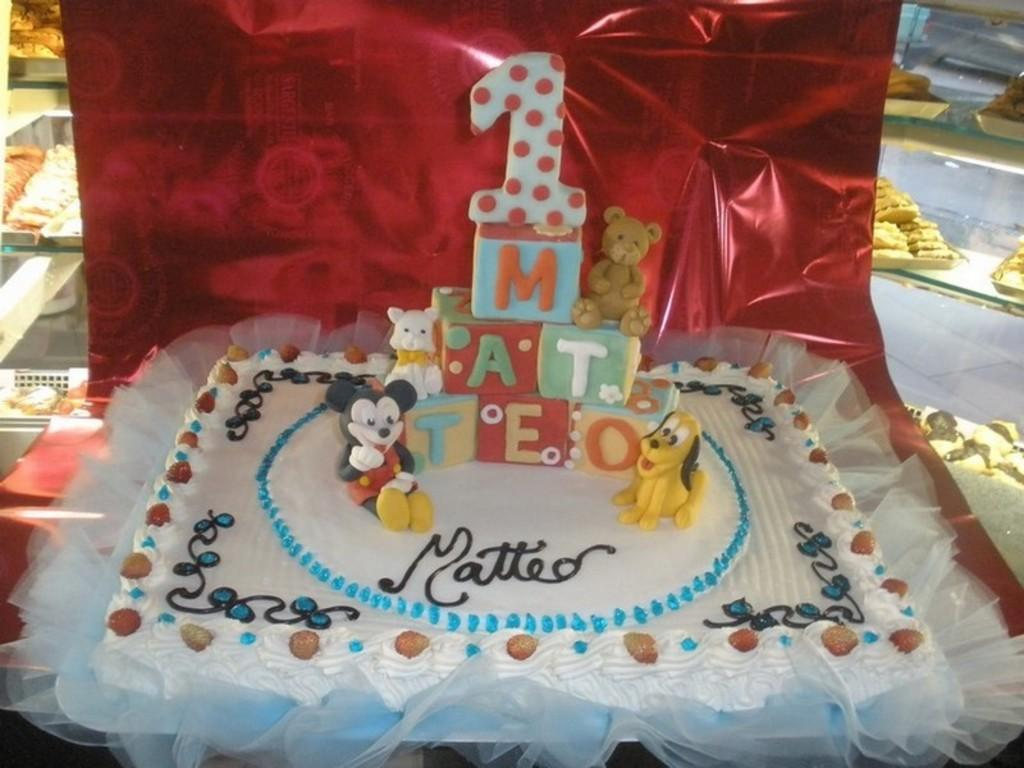What type of dessert is the main focus of the image? There is a birthday cake in the image. Are there any other desserts visible in the image? Yes, there are cookies behind the cake in the image. How many family members are present in the image? There is no information about family members in the image, as it only shows a birthday cake and cookies. What type of cream is used to decorate the cake in the image? There is no information about the type of cream used to decorate the cake in the image. 